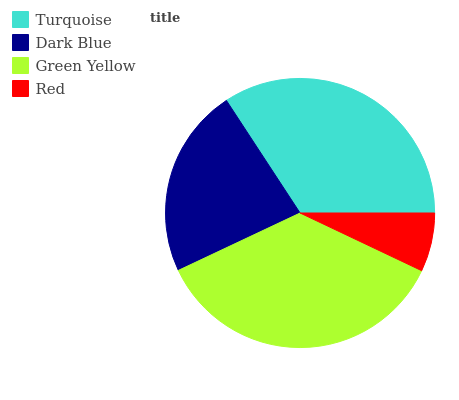Is Red the minimum?
Answer yes or no. Yes. Is Green Yellow the maximum?
Answer yes or no. Yes. Is Dark Blue the minimum?
Answer yes or no. No. Is Dark Blue the maximum?
Answer yes or no. No. Is Turquoise greater than Dark Blue?
Answer yes or no. Yes. Is Dark Blue less than Turquoise?
Answer yes or no. Yes. Is Dark Blue greater than Turquoise?
Answer yes or no. No. Is Turquoise less than Dark Blue?
Answer yes or no. No. Is Turquoise the high median?
Answer yes or no. Yes. Is Dark Blue the low median?
Answer yes or no. Yes. Is Green Yellow the high median?
Answer yes or no. No. Is Turquoise the low median?
Answer yes or no. No. 